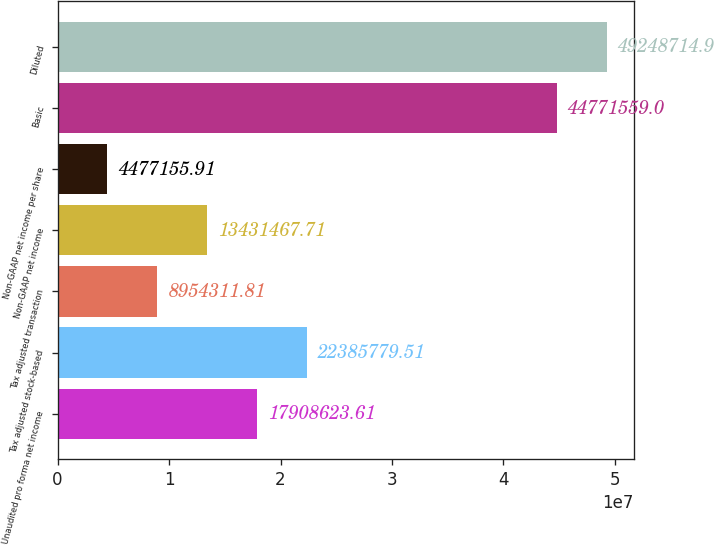Convert chart. <chart><loc_0><loc_0><loc_500><loc_500><bar_chart><fcel>Unaudited pro forma net income<fcel>Tax adjusted stock-based<fcel>Tax adjusted transaction<fcel>Non-GAAP net income<fcel>Non-GAAP net income per share<fcel>Basic<fcel>Diluted<nl><fcel>1.79086e+07<fcel>2.23858e+07<fcel>8.95431e+06<fcel>1.34315e+07<fcel>4.47716e+06<fcel>4.47716e+07<fcel>4.92487e+07<nl></chart> 